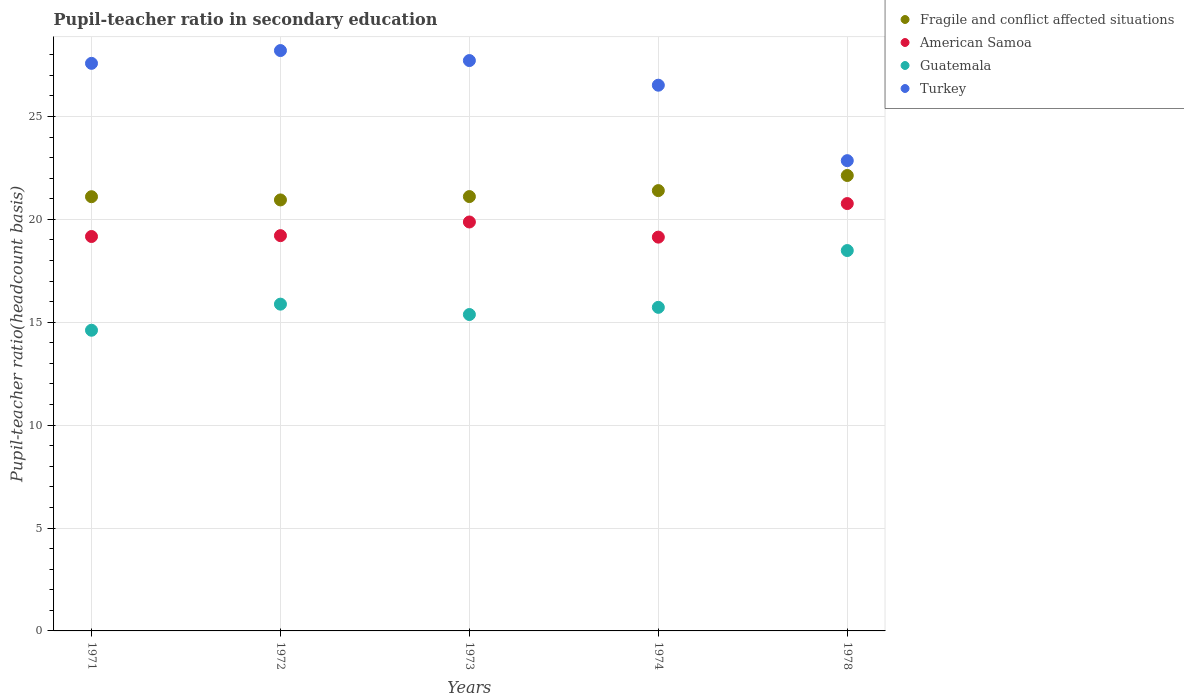How many different coloured dotlines are there?
Keep it short and to the point. 4. What is the pupil-teacher ratio in secondary education in Guatemala in 1974?
Provide a succinct answer. 15.72. Across all years, what is the maximum pupil-teacher ratio in secondary education in Turkey?
Keep it short and to the point. 28.2. Across all years, what is the minimum pupil-teacher ratio in secondary education in American Samoa?
Provide a short and direct response. 19.14. In which year was the pupil-teacher ratio in secondary education in Fragile and conflict affected situations maximum?
Provide a short and direct response. 1978. In which year was the pupil-teacher ratio in secondary education in American Samoa minimum?
Your response must be concise. 1974. What is the total pupil-teacher ratio in secondary education in Fragile and conflict affected situations in the graph?
Offer a very short reply. 106.68. What is the difference between the pupil-teacher ratio in secondary education in Turkey in 1971 and that in 1974?
Keep it short and to the point. 1.06. What is the difference between the pupil-teacher ratio in secondary education in American Samoa in 1972 and the pupil-teacher ratio in secondary education in Guatemala in 1978?
Your answer should be very brief. 0.72. What is the average pupil-teacher ratio in secondary education in Fragile and conflict affected situations per year?
Offer a terse response. 21.34. In the year 1973, what is the difference between the pupil-teacher ratio in secondary education in Fragile and conflict affected situations and pupil-teacher ratio in secondary education in Turkey?
Your answer should be very brief. -6.61. In how many years, is the pupil-teacher ratio in secondary education in American Samoa greater than 25?
Provide a succinct answer. 0. What is the ratio of the pupil-teacher ratio in secondary education in Guatemala in 1972 to that in 1973?
Provide a succinct answer. 1.03. What is the difference between the highest and the second highest pupil-teacher ratio in secondary education in Guatemala?
Your answer should be very brief. 2.6. What is the difference between the highest and the lowest pupil-teacher ratio in secondary education in Guatemala?
Your response must be concise. 3.87. Is it the case that in every year, the sum of the pupil-teacher ratio in secondary education in Fragile and conflict affected situations and pupil-teacher ratio in secondary education in Turkey  is greater than the sum of pupil-teacher ratio in secondary education in American Samoa and pupil-teacher ratio in secondary education in Guatemala?
Offer a terse response. No. Is it the case that in every year, the sum of the pupil-teacher ratio in secondary education in Guatemala and pupil-teacher ratio in secondary education in Turkey  is greater than the pupil-teacher ratio in secondary education in Fragile and conflict affected situations?
Your answer should be very brief. Yes. Is the pupil-teacher ratio in secondary education in American Samoa strictly greater than the pupil-teacher ratio in secondary education in Fragile and conflict affected situations over the years?
Provide a succinct answer. No. Is the pupil-teacher ratio in secondary education in Fragile and conflict affected situations strictly less than the pupil-teacher ratio in secondary education in Guatemala over the years?
Offer a terse response. No. How many dotlines are there?
Your answer should be very brief. 4. How many years are there in the graph?
Keep it short and to the point. 5. What is the difference between two consecutive major ticks on the Y-axis?
Your response must be concise. 5. Does the graph contain grids?
Provide a succinct answer. Yes. Where does the legend appear in the graph?
Your answer should be compact. Top right. How many legend labels are there?
Your answer should be compact. 4. What is the title of the graph?
Your answer should be very brief. Pupil-teacher ratio in secondary education. Does "Least developed countries" appear as one of the legend labels in the graph?
Your response must be concise. No. What is the label or title of the X-axis?
Ensure brevity in your answer.  Years. What is the label or title of the Y-axis?
Ensure brevity in your answer.  Pupil-teacher ratio(headcount basis). What is the Pupil-teacher ratio(headcount basis) of Fragile and conflict affected situations in 1971?
Keep it short and to the point. 21.1. What is the Pupil-teacher ratio(headcount basis) in American Samoa in 1971?
Ensure brevity in your answer.  19.17. What is the Pupil-teacher ratio(headcount basis) in Guatemala in 1971?
Ensure brevity in your answer.  14.61. What is the Pupil-teacher ratio(headcount basis) of Turkey in 1971?
Your answer should be very brief. 27.58. What is the Pupil-teacher ratio(headcount basis) of Fragile and conflict affected situations in 1972?
Give a very brief answer. 20.94. What is the Pupil-teacher ratio(headcount basis) of American Samoa in 1972?
Your answer should be very brief. 19.21. What is the Pupil-teacher ratio(headcount basis) of Guatemala in 1972?
Offer a very short reply. 15.88. What is the Pupil-teacher ratio(headcount basis) in Turkey in 1972?
Provide a succinct answer. 28.2. What is the Pupil-teacher ratio(headcount basis) in Fragile and conflict affected situations in 1973?
Provide a short and direct response. 21.11. What is the Pupil-teacher ratio(headcount basis) in American Samoa in 1973?
Offer a very short reply. 19.87. What is the Pupil-teacher ratio(headcount basis) of Guatemala in 1973?
Provide a succinct answer. 15.38. What is the Pupil-teacher ratio(headcount basis) in Turkey in 1973?
Give a very brief answer. 27.72. What is the Pupil-teacher ratio(headcount basis) in Fragile and conflict affected situations in 1974?
Keep it short and to the point. 21.4. What is the Pupil-teacher ratio(headcount basis) in American Samoa in 1974?
Make the answer very short. 19.14. What is the Pupil-teacher ratio(headcount basis) in Guatemala in 1974?
Ensure brevity in your answer.  15.72. What is the Pupil-teacher ratio(headcount basis) of Turkey in 1974?
Make the answer very short. 26.52. What is the Pupil-teacher ratio(headcount basis) of Fragile and conflict affected situations in 1978?
Your answer should be compact. 22.13. What is the Pupil-teacher ratio(headcount basis) of American Samoa in 1978?
Make the answer very short. 20.77. What is the Pupil-teacher ratio(headcount basis) in Guatemala in 1978?
Provide a short and direct response. 18.48. What is the Pupil-teacher ratio(headcount basis) of Turkey in 1978?
Provide a short and direct response. 22.85. Across all years, what is the maximum Pupil-teacher ratio(headcount basis) of Fragile and conflict affected situations?
Provide a succinct answer. 22.13. Across all years, what is the maximum Pupil-teacher ratio(headcount basis) in American Samoa?
Ensure brevity in your answer.  20.77. Across all years, what is the maximum Pupil-teacher ratio(headcount basis) in Guatemala?
Keep it short and to the point. 18.48. Across all years, what is the maximum Pupil-teacher ratio(headcount basis) of Turkey?
Give a very brief answer. 28.2. Across all years, what is the minimum Pupil-teacher ratio(headcount basis) of Fragile and conflict affected situations?
Your answer should be compact. 20.94. Across all years, what is the minimum Pupil-teacher ratio(headcount basis) of American Samoa?
Your answer should be compact. 19.14. Across all years, what is the minimum Pupil-teacher ratio(headcount basis) of Guatemala?
Make the answer very short. 14.61. Across all years, what is the minimum Pupil-teacher ratio(headcount basis) of Turkey?
Make the answer very short. 22.85. What is the total Pupil-teacher ratio(headcount basis) of Fragile and conflict affected situations in the graph?
Your response must be concise. 106.68. What is the total Pupil-teacher ratio(headcount basis) of American Samoa in the graph?
Make the answer very short. 98.15. What is the total Pupil-teacher ratio(headcount basis) of Guatemala in the graph?
Offer a very short reply. 80.08. What is the total Pupil-teacher ratio(headcount basis) of Turkey in the graph?
Offer a very short reply. 132.87. What is the difference between the Pupil-teacher ratio(headcount basis) of Fragile and conflict affected situations in 1971 and that in 1972?
Provide a short and direct response. 0.16. What is the difference between the Pupil-teacher ratio(headcount basis) in American Samoa in 1971 and that in 1972?
Provide a succinct answer. -0.04. What is the difference between the Pupil-teacher ratio(headcount basis) of Guatemala in 1971 and that in 1972?
Make the answer very short. -1.27. What is the difference between the Pupil-teacher ratio(headcount basis) of Turkey in 1971 and that in 1972?
Give a very brief answer. -0.62. What is the difference between the Pupil-teacher ratio(headcount basis) in Fragile and conflict affected situations in 1971 and that in 1973?
Offer a very short reply. -0.01. What is the difference between the Pupil-teacher ratio(headcount basis) of American Samoa in 1971 and that in 1973?
Provide a short and direct response. -0.71. What is the difference between the Pupil-teacher ratio(headcount basis) of Guatemala in 1971 and that in 1973?
Your answer should be very brief. -0.76. What is the difference between the Pupil-teacher ratio(headcount basis) in Turkey in 1971 and that in 1973?
Your answer should be very brief. -0.14. What is the difference between the Pupil-teacher ratio(headcount basis) in Fragile and conflict affected situations in 1971 and that in 1974?
Make the answer very short. -0.3. What is the difference between the Pupil-teacher ratio(headcount basis) of American Samoa in 1971 and that in 1974?
Your answer should be very brief. 0.03. What is the difference between the Pupil-teacher ratio(headcount basis) in Guatemala in 1971 and that in 1974?
Offer a terse response. -1.11. What is the difference between the Pupil-teacher ratio(headcount basis) of Turkey in 1971 and that in 1974?
Provide a succinct answer. 1.06. What is the difference between the Pupil-teacher ratio(headcount basis) in Fragile and conflict affected situations in 1971 and that in 1978?
Your answer should be compact. -1.03. What is the difference between the Pupil-teacher ratio(headcount basis) in American Samoa in 1971 and that in 1978?
Provide a short and direct response. -1.6. What is the difference between the Pupil-teacher ratio(headcount basis) in Guatemala in 1971 and that in 1978?
Offer a terse response. -3.87. What is the difference between the Pupil-teacher ratio(headcount basis) in Turkey in 1971 and that in 1978?
Ensure brevity in your answer.  4.73. What is the difference between the Pupil-teacher ratio(headcount basis) in Fragile and conflict affected situations in 1972 and that in 1973?
Keep it short and to the point. -0.16. What is the difference between the Pupil-teacher ratio(headcount basis) in American Samoa in 1972 and that in 1973?
Provide a short and direct response. -0.66. What is the difference between the Pupil-teacher ratio(headcount basis) of Guatemala in 1972 and that in 1973?
Your answer should be compact. 0.5. What is the difference between the Pupil-teacher ratio(headcount basis) in Turkey in 1972 and that in 1973?
Provide a succinct answer. 0.49. What is the difference between the Pupil-teacher ratio(headcount basis) of Fragile and conflict affected situations in 1972 and that in 1974?
Provide a short and direct response. -0.45. What is the difference between the Pupil-teacher ratio(headcount basis) of American Samoa in 1972 and that in 1974?
Provide a succinct answer. 0.07. What is the difference between the Pupil-teacher ratio(headcount basis) of Guatemala in 1972 and that in 1974?
Give a very brief answer. 0.16. What is the difference between the Pupil-teacher ratio(headcount basis) in Turkey in 1972 and that in 1974?
Keep it short and to the point. 1.68. What is the difference between the Pupil-teacher ratio(headcount basis) of Fragile and conflict affected situations in 1972 and that in 1978?
Provide a succinct answer. -1.19. What is the difference between the Pupil-teacher ratio(headcount basis) in American Samoa in 1972 and that in 1978?
Your answer should be very brief. -1.56. What is the difference between the Pupil-teacher ratio(headcount basis) of Guatemala in 1972 and that in 1978?
Provide a succinct answer. -2.6. What is the difference between the Pupil-teacher ratio(headcount basis) of Turkey in 1972 and that in 1978?
Make the answer very short. 5.35. What is the difference between the Pupil-teacher ratio(headcount basis) of Fragile and conflict affected situations in 1973 and that in 1974?
Provide a short and direct response. -0.29. What is the difference between the Pupil-teacher ratio(headcount basis) in American Samoa in 1973 and that in 1974?
Keep it short and to the point. 0.74. What is the difference between the Pupil-teacher ratio(headcount basis) of Guatemala in 1973 and that in 1974?
Your answer should be very brief. -0.35. What is the difference between the Pupil-teacher ratio(headcount basis) of Turkey in 1973 and that in 1974?
Give a very brief answer. 1.2. What is the difference between the Pupil-teacher ratio(headcount basis) in Fragile and conflict affected situations in 1973 and that in 1978?
Offer a very short reply. -1.02. What is the difference between the Pupil-teacher ratio(headcount basis) of American Samoa in 1973 and that in 1978?
Provide a succinct answer. -0.9. What is the difference between the Pupil-teacher ratio(headcount basis) in Guatemala in 1973 and that in 1978?
Keep it short and to the point. -3.11. What is the difference between the Pupil-teacher ratio(headcount basis) of Turkey in 1973 and that in 1978?
Provide a succinct answer. 4.86. What is the difference between the Pupil-teacher ratio(headcount basis) of Fragile and conflict affected situations in 1974 and that in 1978?
Provide a short and direct response. -0.73. What is the difference between the Pupil-teacher ratio(headcount basis) of American Samoa in 1974 and that in 1978?
Keep it short and to the point. -1.63. What is the difference between the Pupil-teacher ratio(headcount basis) in Guatemala in 1974 and that in 1978?
Your answer should be compact. -2.76. What is the difference between the Pupil-teacher ratio(headcount basis) of Turkey in 1974 and that in 1978?
Your answer should be compact. 3.67. What is the difference between the Pupil-teacher ratio(headcount basis) in Fragile and conflict affected situations in 1971 and the Pupil-teacher ratio(headcount basis) in American Samoa in 1972?
Make the answer very short. 1.89. What is the difference between the Pupil-teacher ratio(headcount basis) of Fragile and conflict affected situations in 1971 and the Pupil-teacher ratio(headcount basis) of Guatemala in 1972?
Offer a terse response. 5.22. What is the difference between the Pupil-teacher ratio(headcount basis) in Fragile and conflict affected situations in 1971 and the Pupil-teacher ratio(headcount basis) in Turkey in 1972?
Your response must be concise. -7.1. What is the difference between the Pupil-teacher ratio(headcount basis) of American Samoa in 1971 and the Pupil-teacher ratio(headcount basis) of Guatemala in 1972?
Your answer should be very brief. 3.29. What is the difference between the Pupil-teacher ratio(headcount basis) of American Samoa in 1971 and the Pupil-teacher ratio(headcount basis) of Turkey in 1972?
Make the answer very short. -9.04. What is the difference between the Pupil-teacher ratio(headcount basis) of Guatemala in 1971 and the Pupil-teacher ratio(headcount basis) of Turkey in 1972?
Ensure brevity in your answer.  -13.59. What is the difference between the Pupil-teacher ratio(headcount basis) of Fragile and conflict affected situations in 1971 and the Pupil-teacher ratio(headcount basis) of American Samoa in 1973?
Make the answer very short. 1.23. What is the difference between the Pupil-teacher ratio(headcount basis) of Fragile and conflict affected situations in 1971 and the Pupil-teacher ratio(headcount basis) of Guatemala in 1973?
Ensure brevity in your answer.  5.73. What is the difference between the Pupil-teacher ratio(headcount basis) of Fragile and conflict affected situations in 1971 and the Pupil-teacher ratio(headcount basis) of Turkey in 1973?
Offer a very short reply. -6.62. What is the difference between the Pupil-teacher ratio(headcount basis) in American Samoa in 1971 and the Pupil-teacher ratio(headcount basis) in Guatemala in 1973?
Keep it short and to the point. 3.79. What is the difference between the Pupil-teacher ratio(headcount basis) in American Samoa in 1971 and the Pupil-teacher ratio(headcount basis) in Turkey in 1973?
Keep it short and to the point. -8.55. What is the difference between the Pupil-teacher ratio(headcount basis) of Guatemala in 1971 and the Pupil-teacher ratio(headcount basis) of Turkey in 1973?
Make the answer very short. -13.1. What is the difference between the Pupil-teacher ratio(headcount basis) in Fragile and conflict affected situations in 1971 and the Pupil-teacher ratio(headcount basis) in American Samoa in 1974?
Your response must be concise. 1.96. What is the difference between the Pupil-teacher ratio(headcount basis) in Fragile and conflict affected situations in 1971 and the Pupil-teacher ratio(headcount basis) in Guatemala in 1974?
Provide a succinct answer. 5.38. What is the difference between the Pupil-teacher ratio(headcount basis) in Fragile and conflict affected situations in 1971 and the Pupil-teacher ratio(headcount basis) in Turkey in 1974?
Make the answer very short. -5.42. What is the difference between the Pupil-teacher ratio(headcount basis) in American Samoa in 1971 and the Pupil-teacher ratio(headcount basis) in Guatemala in 1974?
Ensure brevity in your answer.  3.44. What is the difference between the Pupil-teacher ratio(headcount basis) in American Samoa in 1971 and the Pupil-teacher ratio(headcount basis) in Turkey in 1974?
Ensure brevity in your answer.  -7.35. What is the difference between the Pupil-teacher ratio(headcount basis) in Guatemala in 1971 and the Pupil-teacher ratio(headcount basis) in Turkey in 1974?
Your response must be concise. -11.91. What is the difference between the Pupil-teacher ratio(headcount basis) in Fragile and conflict affected situations in 1971 and the Pupil-teacher ratio(headcount basis) in American Samoa in 1978?
Offer a very short reply. 0.33. What is the difference between the Pupil-teacher ratio(headcount basis) in Fragile and conflict affected situations in 1971 and the Pupil-teacher ratio(headcount basis) in Guatemala in 1978?
Your answer should be very brief. 2.62. What is the difference between the Pupil-teacher ratio(headcount basis) in Fragile and conflict affected situations in 1971 and the Pupil-teacher ratio(headcount basis) in Turkey in 1978?
Keep it short and to the point. -1.75. What is the difference between the Pupil-teacher ratio(headcount basis) of American Samoa in 1971 and the Pupil-teacher ratio(headcount basis) of Guatemala in 1978?
Offer a very short reply. 0.68. What is the difference between the Pupil-teacher ratio(headcount basis) of American Samoa in 1971 and the Pupil-teacher ratio(headcount basis) of Turkey in 1978?
Provide a succinct answer. -3.69. What is the difference between the Pupil-teacher ratio(headcount basis) of Guatemala in 1971 and the Pupil-teacher ratio(headcount basis) of Turkey in 1978?
Provide a short and direct response. -8.24. What is the difference between the Pupil-teacher ratio(headcount basis) in Fragile and conflict affected situations in 1972 and the Pupil-teacher ratio(headcount basis) in American Samoa in 1973?
Give a very brief answer. 1.07. What is the difference between the Pupil-teacher ratio(headcount basis) of Fragile and conflict affected situations in 1972 and the Pupil-teacher ratio(headcount basis) of Guatemala in 1973?
Your answer should be very brief. 5.57. What is the difference between the Pupil-teacher ratio(headcount basis) of Fragile and conflict affected situations in 1972 and the Pupil-teacher ratio(headcount basis) of Turkey in 1973?
Give a very brief answer. -6.77. What is the difference between the Pupil-teacher ratio(headcount basis) of American Samoa in 1972 and the Pupil-teacher ratio(headcount basis) of Guatemala in 1973?
Offer a very short reply. 3.83. What is the difference between the Pupil-teacher ratio(headcount basis) of American Samoa in 1972 and the Pupil-teacher ratio(headcount basis) of Turkey in 1973?
Offer a very short reply. -8.51. What is the difference between the Pupil-teacher ratio(headcount basis) in Guatemala in 1972 and the Pupil-teacher ratio(headcount basis) in Turkey in 1973?
Ensure brevity in your answer.  -11.84. What is the difference between the Pupil-teacher ratio(headcount basis) of Fragile and conflict affected situations in 1972 and the Pupil-teacher ratio(headcount basis) of American Samoa in 1974?
Your answer should be compact. 1.81. What is the difference between the Pupil-teacher ratio(headcount basis) in Fragile and conflict affected situations in 1972 and the Pupil-teacher ratio(headcount basis) in Guatemala in 1974?
Offer a very short reply. 5.22. What is the difference between the Pupil-teacher ratio(headcount basis) of Fragile and conflict affected situations in 1972 and the Pupil-teacher ratio(headcount basis) of Turkey in 1974?
Your answer should be very brief. -5.58. What is the difference between the Pupil-teacher ratio(headcount basis) in American Samoa in 1972 and the Pupil-teacher ratio(headcount basis) in Guatemala in 1974?
Your response must be concise. 3.48. What is the difference between the Pupil-teacher ratio(headcount basis) of American Samoa in 1972 and the Pupil-teacher ratio(headcount basis) of Turkey in 1974?
Keep it short and to the point. -7.31. What is the difference between the Pupil-teacher ratio(headcount basis) of Guatemala in 1972 and the Pupil-teacher ratio(headcount basis) of Turkey in 1974?
Ensure brevity in your answer.  -10.64. What is the difference between the Pupil-teacher ratio(headcount basis) of Fragile and conflict affected situations in 1972 and the Pupil-teacher ratio(headcount basis) of American Samoa in 1978?
Your response must be concise. 0.18. What is the difference between the Pupil-teacher ratio(headcount basis) in Fragile and conflict affected situations in 1972 and the Pupil-teacher ratio(headcount basis) in Guatemala in 1978?
Provide a succinct answer. 2.46. What is the difference between the Pupil-teacher ratio(headcount basis) in Fragile and conflict affected situations in 1972 and the Pupil-teacher ratio(headcount basis) in Turkey in 1978?
Keep it short and to the point. -1.91. What is the difference between the Pupil-teacher ratio(headcount basis) of American Samoa in 1972 and the Pupil-teacher ratio(headcount basis) of Guatemala in 1978?
Your answer should be compact. 0.72. What is the difference between the Pupil-teacher ratio(headcount basis) of American Samoa in 1972 and the Pupil-teacher ratio(headcount basis) of Turkey in 1978?
Offer a very short reply. -3.64. What is the difference between the Pupil-teacher ratio(headcount basis) in Guatemala in 1972 and the Pupil-teacher ratio(headcount basis) in Turkey in 1978?
Give a very brief answer. -6.97. What is the difference between the Pupil-teacher ratio(headcount basis) in Fragile and conflict affected situations in 1973 and the Pupil-teacher ratio(headcount basis) in American Samoa in 1974?
Your response must be concise. 1.97. What is the difference between the Pupil-teacher ratio(headcount basis) in Fragile and conflict affected situations in 1973 and the Pupil-teacher ratio(headcount basis) in Guatemala in 1974?
Give a very brief answer. 5.38. What is the difference between the Pupil-teacher ratio(headcount basis) of Fragile and conflict affected situations in 1973 and the Pupil-teacher ratio(headcount basis) of Turkey in 1974?
Give a very brief answer. -5.41. What is the difference between the Pupil-teacher ratio(headcount basis) in American Samoa in 1973 and the Pupil-teacher ratio(headcount basis) in Guatemala in 1974?
Offer a very short reply. 4.15. What is the difference between the Pupil-teacher ratio(headcount basis) of American Samoa in 1973 and the Pupil-teacher ratio(headcount basis) of Turkey in 1974?
Make the answer very short. -6.65. What is the difference between the Pupil-teacher ratio(headcount basis) in Guatemala in 1973 and the Pupil-teacher ratio(headcount basis) in Turkey in 1974?
Offer a terse response. -11.14. What is the difference between the Pupil-teacher ratio(headcount basis) of Fragile and conflict affected situations in 1973 and the Pupil-teacher ratio(headcount basis) of American Samoa in 1978?
Give a very brief answer. 0.34. What is the difference between the Pupil-teacher ratio(headcount basis) of Fragile and conflict affected situations in 1973 and the Pupil-teacher ratio(headcount basis) of Guatemala in 1978?
Your answer should be very brief. 2.62. What is the difference between the Pupil-teacher ratio(headcount basis) of Fragile and conflict affected situations in 1973 and the Pupil-teacher ratio(headcount basis) of Turkey in 1978?
Make the answer very short. -1.75. What is the difference between the Pupil-teacher ratio(headcount basis) in American Samoa in 1973 and the Pupil-teacher ratio(headcount basis) in Guatemala in 1978?
Make the answer very short. 1.39. What is the difference between the Pupil-teacher ratio(headcount basis) of American Samoa in 1973 and the Pupil-teacher ratio(headcount basis) of Turkey in 1978?
Give a very brief answer. -2.98. What is the difference between the Pupil-teacher ratio(headcount basis) of Guatemala in 1973 and the Pupil-teacher ratio(headcount basis) of Turkey in 1978?
Offer a terse response. -7.48. What is the difference between the Pupil-teacher ratio(headcount basis) in Fragile and conflict affected situations in 1974 and the Pupil-teacher ratio(headcount basis) in American Samoa in 1978?
Your answer should be compact. 0.63. What is the difference between the Pupil-teacher ratio(headcount basis) in Fragile and conflict affected situations in 1974 and the Pupil-teacher ratio(headcount basis) in Guatemala in 1978?
Offer a terse response. 2.91. What is the difference between the Pupil-teacher ratio(headcount basis) of Fragile and conflict affected situations in 1974 and the Pupil-teacher ratio(headcount basis) of Turkey in 1978?
Give a very brief answer. -1.46. What is the difference between the Pupil-teacher ratio(headcount basis) in American Samoa in 1974 and the Pupil-teacher ratio(headcount basis) in Guatemala in 1978?
Your response must be concise. 0.65. What is the difference between the Pupil-teacher ratio(headcount basis) of American Samoa in 1974 and the Pupil-teacher ratio(headcount basis) of Turkey in 1978?
Your answer should be very brief. -3.72. What is the difference between the Pupil-teacher ratio(headcount basis) of Guatemala in 1974 and the Pupil-teacher ratio(headcount basis) of Turkey in 1978?
Make the answer very short. -7.13. What is the average Pupil-teacher ratio(headcount basis) in Fragile and conflict affected situations per year?
Keep it short and to the point. 21.34. What is the average Pupil-teacher ratio(headcount basis) in American Samoa per year?
Offer a terse response. 19.63. What is the average Pupil-teacher ratio(headcount basis) in Guatemala per year?
Offer a terse response. 16.02. What is the average Pupil-teacher ratio(headcount basis) in Turkey per year?
Offer a very short reply. 26.57. In the year 1971, what is the difference between the Pupil-teacher ratio(headcount basis) of Fragile and conflict affected situations and Pupil-teacher ratio(headcount basis) of American Samoa?
Offer a terse response. 1.93. In the year 1971, what is the difference between the Pupil-teacher ratio(headcount basis) in Fragile and conflict affected situations and Pupil-teacher ratio(headcount basis) in Guatemala?
Your answer should be compact. 6.49. In the year 1971, what is the difference between the Pupil-teacher ratio(headcount basis) in Fragile and conflict affected situations and Pupil-teacher ratio(headcount basis) in Turkey?
Your response must be concise. -6.48. In the year 1971, what is the difference between the Pupil-teacher ratio(headcount basis) of American Samoa and Pupil-teacher ratio(headcount basis) of Guatemala?
Ensure brevity in your answer.  4.56. In the year 1971, what is the difference between the Pupil-teacher ratio(headcount basis) in American Samoa and Pupil-teacher ratio(headcount basis) in Turkey?
Offer a very short reply. -8.41. In the year 1971, what is the difference between the Pupil-teacher ratio(headcount basis) in Guatemala and Pupil-teacher ratio(headcount basis) in Turkey?
Provide a succinct answer. -12.97. In the year 1972, what is the difference between the Pupil-teacher ratio(headcount basis) of Fragile and conflict affected situations and Pupil-teacher ratio(headcount basis) of American Samoa?
Offer a very short reply. 1.74. In the year 1972, what is the difference between the Pupil-teacher ratio(headcount basis) in Fragile and conflict affected situations and Pupil-teacher ratio(headcount basis) in Guatemala?
Provide a short and direct response. 5.06. In the year 1972, what is the difference between the Pupil-teacher ratio(headcount basis) of Fragile and conflict affected situations and Pupil-teacher ratio(headcount basis) of Turkey?
Ensure brevity in your answer.  -7.26. In the year 1972, what is the difference between the Pupil-teacher ratio(headcount basis) in American Samoa and Pupil-teacher ratio(headcount basis) in Guatemala?
Give a very brief answer. 3.33. In the year 1972, what is the difference between the Pupil-teacher ratio(headcount basis) in American Samoa and Pupil-teacher ratio(headcount basis) in Turkey?
Offer a very short reply. -8.99. In the year 1972, what is the difference between the Pupil-teacher ratio(headcount basis) in Guatemala and Pupil-teacher ratio(headcount basis) in Turkey?
Offer a terse response. -12.32. In the year 1973, what is the difference between the Pupil-teacher ratio(headcount basis) in Fragile and conflict affected situations and Pupil-teacher ratio(headcount basis) in American Samoa?
Provide a short and direct response. 1.24. In the year 1973, what is the difference between the Pupil-teacher ratio(headcount basis) of Fragile and conflict affected situations and Pupil-teacher ratio(headcount basis) of Guatemala?
Offer a very short reply. 5.73. In the year 1973, what is the difference between the Pupil-teacher ratio(headcount basis) of Fragile and conflict affected situations and Pupil-teacher ratio(headcount basis) of Turkey?
Your response must be concise. -6.61. In the year 1973, what is the difference between the Pupil-teacher ratio(headcount basis) in American Samoa and Pupil-teacher ratio(headcount basis) in Guatemala?
Offer a terse response. 4.5. In the year 1973, what is the difference between the Pupil-teacher ratio(headcount basis) of American Samoa and Pupil-teacher ratio(headcount basis) of Turkey?
Ensure brevity in your answer.  -7.84. In the year 1973, what is the difference between the Pupil-teacher ratio(headcount basis) of Guatemala and Pupil-teacher ratio(headcount basis) of Turkey?
Give a very brief answer. -12.34. In the year 1974, what is the difference between the Pupil-teacher ratio(headcount basis) in Fragile and conflict affected situations and Pupil-teacher ratio(headcount basis) in American Samoa?
Your answer should be very brief. 2.26. In the year 1974, what is the difference between the Pupil-teacher ratio(headcount basis) in Fragile and conflict affected situations and Pupil-teacher ratio(headcount basis) in Guatemala?
Provide a short and direct response. 5.67. In the year 1974, what is the difference between the Pupil-teacher ratio(headcount basis) of Fragile and conflict affected situations and Pupil-teacher ratio(headcount basis) of Turkey?
Give a very brief answer. -5.12. In the year 1974, what is the difference between the Pupil-teacher ratio(headcount basis) in American Samoa and Pupil-teacher ratio(headcount basis) in Guatemala?
Your response must be concise. 3.41. In the year 1974, what is the difference between the Pupil-teacher ratio(headcount basis) in American Samoa and Pupil-teacher ratio(headcount basis) in Turkey?
Offer a terse response. -7.38. In the year 1974, what is the difference between the Pupil-teacher ratio(headcount basis) in Guatemala and Pupil-teacher ratio(headcount basis) in Turkey?
Offer a terse response. -10.79. In the year 1978, what is the difference between the Pupil-teacher ratio(headcount basis) of Fragile and conflict affected situations and Pupil-teacher ratio(headcount basis) of American Samoa?
Offer a terse response. 1.36. In the year 1978, what is the difference between the Pupil-teacher ratio(headcount basis) of Fragile and conflict affected situations and Pupil-teacher ratio(headcount basis) of Guatemala?
Give a very brief answer. 3.65. In the year 1978, what is the difference between the Pupil-teacher ratio(headcount basis) in Fragile and conflict affected situations and Pupil-teacher ratio(headcount basis) in Turkey?
Give a very brief answer. -0.72. In the year 1978, what is the difference between the Pupil-teacher ratio(headcount basis) of American Samoa and Pupil-teacher ratio(headcount basis) of Guatemala?
Offer a terse response. 2.28. In the year 1978, what is the difference between the Pupil-teacher ratio(headcount basis) in American Samoa and Pupil-teacher ratio(headcount basis) in Turkey?
Offer a very short reply. -2.08. In the year 1978, what is the difference between the Pupil-teacher ratio(headcount basis) of Guatemala and Pupil-teacher ratio(headcount basis) of Turkey?
Provide a succinct answer. -4.37. What is the ratio of the Pupil-teacher ratio(headcount basis) in Fragile and conflict affected situations in 1971 to that in 1972?
Provide a succinct answer. 1.01. What is the ratio of the Pupil-teacher ratio(headcount basis) in Guatemala in 1971 to that in 1972?
Keep it short and to the point. 0.92. What is the ratio of the Pupil-teacher ratio(headcount basis) in Turkey in 1971 to that in 1972?
Your answer should be compact. 0.98. What is the ratio of the Pupil-teacher ratio(headcount basis) of Fragile and conflict affected situations in 1971 to that in 1973?
Offer a very short reply. 1. What is the ratio of the Pupil-teacher ratio(headcount basis) in American Samoa in 1971 to that in 1973?
Provide a succinct answer. 0.96. What is the ratio of the Pupil-teacher ratio(headcount basis) of Guatemala in 1971 to that in 1973?
Make the answer very short. 0.95. What is the ratio of the Pupil-teacher ratio(headcount basis) of Turkey in 1971 to that in 1973?
Your answer should be very brief. 1. What is the ratio of the Pupil-teacher ratio(headcount basis) in Fragile and conflict affected situations in 1971 to that in 1974?
Provide a succinct answer. 0.99. What is the ratio of the Pupil-teacher ratio(headcount basis) of Guatemala in 1971 to that in 1974?
Provide a succinct answer. 0.93. What is the ratio of the Pupil-teacher ratio(headcount basis) in Fragile and conflict affected situations in 1971 to that in 1978?
Keep it short and to the point. 0.95. What is the ratio of the Pupil-teacher ratio(headcount basis) in American Samoa in 1971 to that in 1978?
Offer a terse response. 0.92. What is the ratio of the Pupil-teacher ratio(headcount basis) of Guatemala in 1971 to that in 1978?
Make the answer very short. 0.79. What is the ratio of the Pupil-teacher ratio(headcount basis) of Turkey in 1971 to that in 1978?
Your answer should be very brief. 1.21. What is the ratio of the Pupil-teacher ratio(headcount basis) in American Samoa in 1972 to that in 1973?
Offer a terse response. 0.97. What is the ratio of the Pupil-teacher ratio(headcount basis) of Guatemala in 1972 to that in 1973?
Make the answer very short. 1.03. What is the ratio of the Pupil-teacher ratio(headcount basis) of Turkey in 1972 to that in 1973?
Provide a succinct answer. 1.02. What is the ratio of the Pupil-teacher ratio(headcount basis) of Fragile and conflict affected situations in 1972 to that in 1974?
Offer a terse response. 0.98. What is the ratio of the Pupil-teacher ratio(headcount basis) of Guatemala in 1972 to that in 1974?
Your answer should be very brief. 1.01. What is the ratio of the Pupil-teacher ratio(headcount basis) of Turkey in 1972 to that in 1974?
Provide a short and direct response. 1.06. What is the ratio of the Pupil-teacher ratio(headcount basis) in Fragile and conflict affected situations in 1972 to that in 1978?
Offer a very short reply. 0.95. What is the ratio of the Pupil-teacher ratio(headcount basis) of American Samoa in 1972 to that in 1978?
Offer a very short reply. 0.92. What is the ratio of the Pupil-teacher ratio(headcount basis) of Guatemala in 1972 to that in 1978?
Ensure brevity in your answer.  0.86. What is the ratio of the Pupil-teacher ratio(headcount basis) in Turkey in 1972 to that in 1978?
Offer a terse response. 1.23. What is the ratio of the Pupil-teacher ratio(headcount basis) of Fragile and conflict affected situations in 1973 to that in 1974?
Offer a terse response. 0.99. What is the ratio of the Pupil-teacher ratio(headcount basis) of Guatemala in 1973 to that in 1974?
Your response must be concise. 0.98. What is the ratio of the Pupil-teacher ratio(headcount basis) in Turkey in 1973 to that in 1974?
Provide a succinct answer. 1.05. What is the ratio of the Pupil-teacher ratio(headcount basis) in Fragile and conflict affected situations in 1973 to that in 1978?
Your answer should be compact. 0.95. What is the ratio of the Pupil-teacher ratio(headcount basis) of American Samoa in 1973 to that in 1978?
Offer a very short reply. 0.96. What is the ratio of the Pupil-teacher ratio(headcount basis) of Guatemala in 1973 to that in 1978?
Your response must be concise. 0.83. What is the ratio of the Pupil-teacher ratio(headcount basis) in Turkey in 1973 to that in 1978?
Provide a short and direct response. 1.21. What is the ratio of the Pupil-teacher ratio(headcount basis) in Fragile and conflict affected situations in 1974 to that in 1978?
Offer a very short reply. 0.97. What is the ratio of the Pupil-teacher ratio(headcount basis) in American Samoa in 1974 to that in 1978?
Offer a very short reply. 0.92. What is the ratio of the Pupil-teacher ratio(headcount basis) in Guatemala in 1974 to that in 1978?
Your answer should be very brief. 0.85. What is the ratio of the Pupil-teacher ratio(headcount basis) in Turkey in 1974 to that in 1978?
Offer a terse response. 1.16. What is the difference between the highest and the second highest Pupil-teacher ratio(headcount basis) of Fragile and conflict affected situations?
Give a very brief answer. 0.73. What is the difference between the highest and the second highest Pupil-teacher ratio(headcount basis) of American Samoa?
Ensure brevity in your answer.  0.9. What is the difference between the highest and the second highest Pupil-teacher ratio(headcount basis) in Guatemala?
Your response must be concise. 2.6. What is the difference between the highest and the second highest Pupil-teacher ratio(headcount basis) of Turkey?
Make the answer very short. 0.49. What is the difference between the highest and the lowest Pupil-teacher ratio(headcount basis) of Fragile and conflict affected situations?
Make the answer very short. 1.19. What is the difference between the highest and the lowest Pupil-teacher ratio(headcount basis) of American Samoa?
Make the answer very short. 1.63. What is the difference between the highest and the lowest Pupil-teacher ratio(headcount basis) of Guatemala?
Keep it short and to the point. 3.87. What is the difference between the highest and the lowest Pupil-teacher ratio(headcount basis) in Turkey?
Offer a terse response. 5.35. 